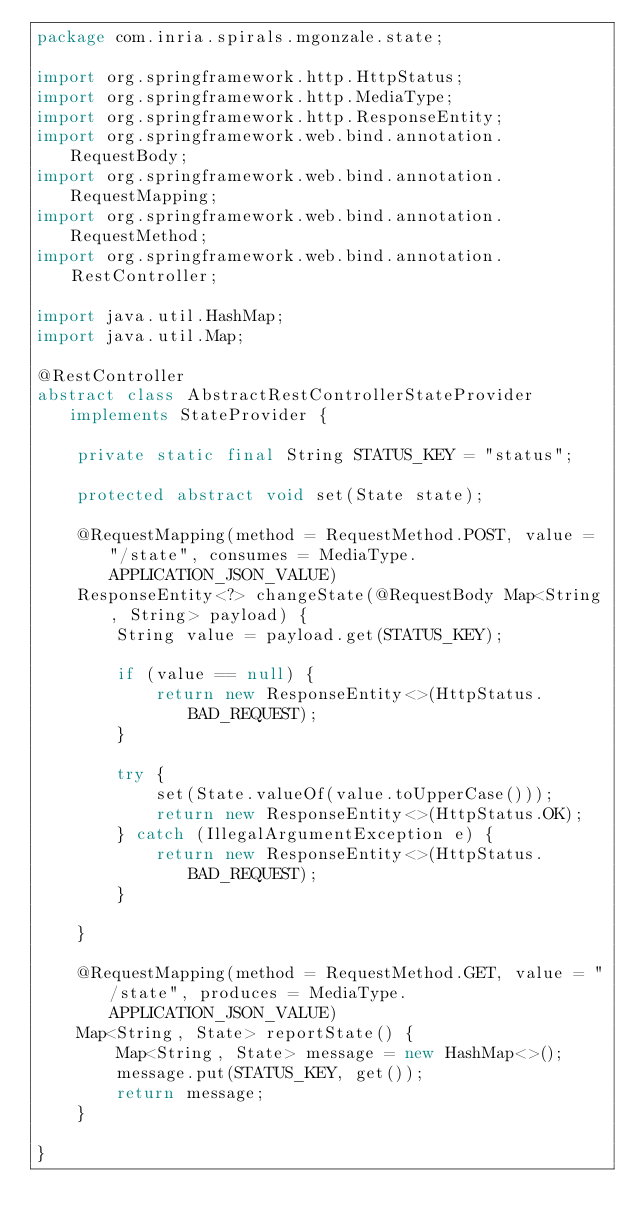<code> <loc_0><loc_0><loc_500><loc_500><_Java_>package com.inria.spirals.mgonzale.state;

import org.springframework.http.HttpStatus;
import org.springframework.http.MediaType;
import org.springframework.http.ResponseEntity;
import org.springframework.web.bind.annotation.RequestBody;
import org.springframework.web.bind.annotation.RequestMapping;
import org.springframework.web.bind.annotation.RequestMethod;
import org.springframework.web.bind.annotation.RestController;

import java.util.HashMap;
import java.util.Map;

@RestController
abstract class AbstractRestControllerStateProvider implements StateProvider {

    private static final String STATUS_KEY = "status";

    protected abstract void set(State state);

    @RequestMapping(method = RequestMethod.POST, value = "/state", consumes = MediaType.APPLICATION_JSON_VALUE)
    ResponseEntity<?> changeState(@RequestBody Map<String, String> payload) {
        String value = payload.get(STATUS_KEY);

        if (value == null) {
            return new ResponseEntity<>(HttpStatus.BAD_REQUEST);
        }

        try {
            set(State.valueOf(value.toUpperCase()));
            return new ResponseEntity<>(HttpStatus.OK);
        } catch (IllegalArgumentException e) {
            return new ResponseEntity<>(HttpStatus.BAD_REQUEST);
        }

    }

    @RequestMapping(method = RequestMethod.GET, value = "/state", produces = MediaType.APPLICATION_JSON_VALUE)
    Map<String, State> reportState() {
        Map<String, State> message = new HashMap<>();
        message.put(STATUS_KEY, get());
        return message;
    }

}
</code> 